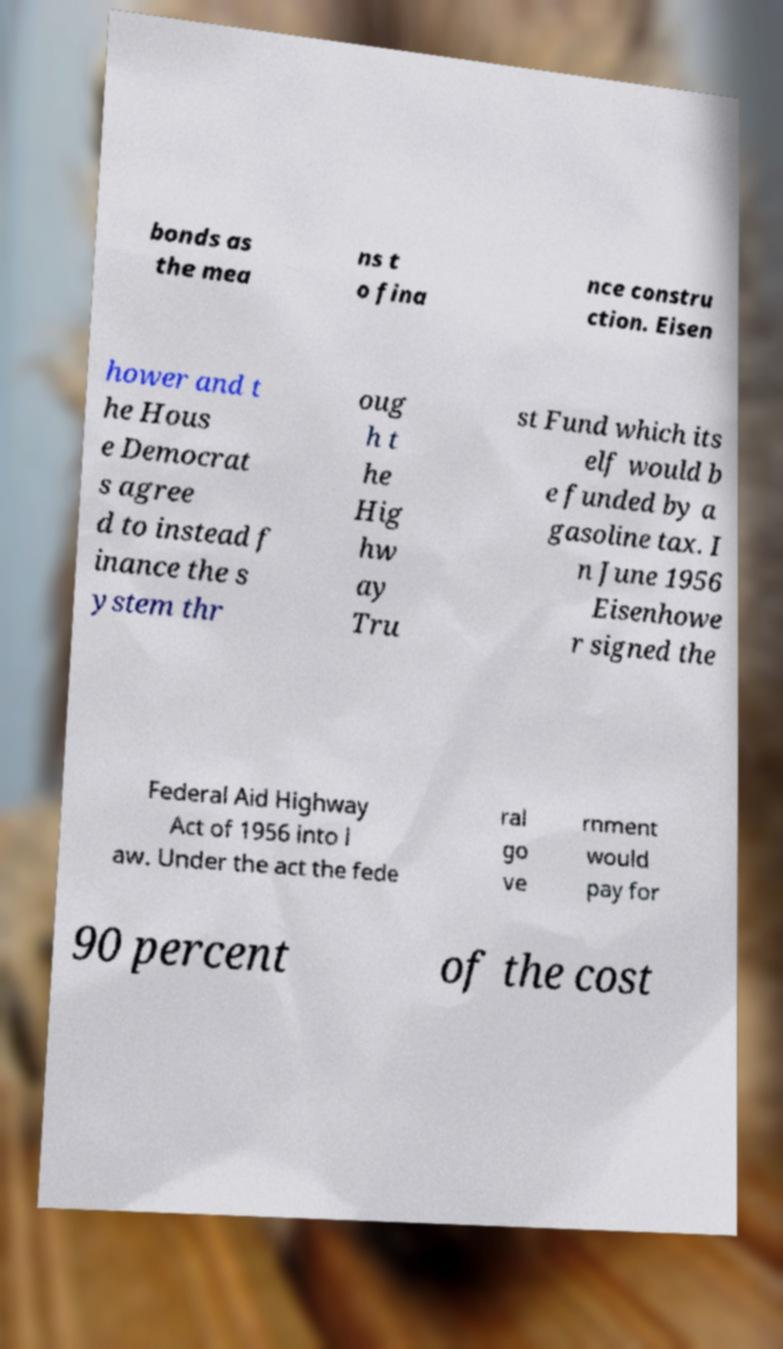Can you read and provide the text displayed in the image?This photo seems to have some interesting text. Can you extract and type it out for me? bonds as the mea ns t o fina nce constru ction. Eisen hower and t he Hous e Democrat s agree d to instead f inance the s ystem thr oug h t he Hig hw ay Tru st Fund which its elf would b e funded by a gasoline tax. I n June 1956 Eisenhowe r signed the Federal Aid Highway Act of 1956 into l aw. Under the act the fede ral go ve rnment would pay for 90 percent of the cost 